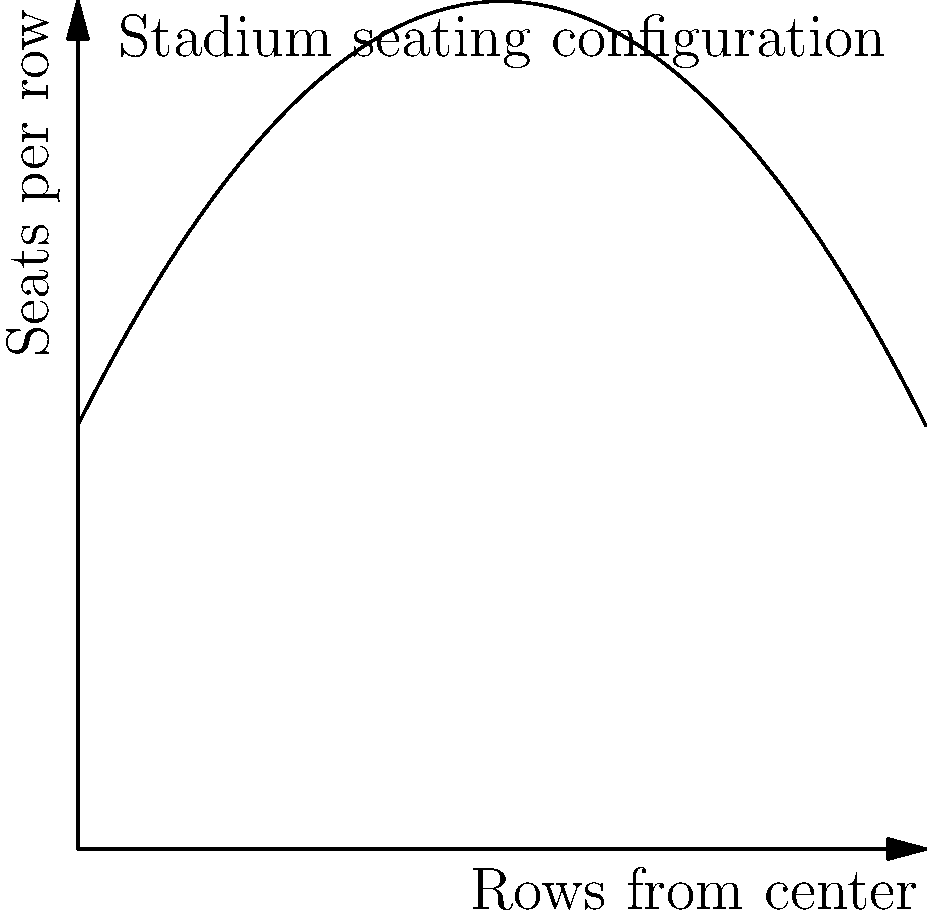The Red Star Belgrade stadium management is planning to optimize seating arrangements. The number of seats in each row can be modeled by the function $S(r) = -0.02r^2 + 2r + 50$, where $r$ is the number of rows from the center. If the stadium has 100 rows on each side of the center, what is the total seating capacity of the stadium? To find the total seating capacity, we need to:

1) Calculate the area under the curve $S(r) = -0.02r^2 + 2r + 50$ from $r=0$ to $r=100$.
2) Multiply this area by 2 to account for both sides of the stadium.

Step 1: Calculate the area under the curve
The area under a curve is given by the definite integral:

$$A = \int_0^{100} (-0.02r^2 + 2r + 50) dr$$

Step 2: Solve the integral
$$A = [-\frac{0.02r^3}{3} + r^2 + 50r]_0^{100}$$
$$A = [-\frac{0.02(100^3)}{3} + 100^2 + 50(100)] - [0]$$
$$A = [-6666.67 + 10000 + 5000] - 0$$
$$A = 8333.33$$

Step 3: Multiply by 2 for both sides of the stadium
Total capacity $= 2 \times 8333.33 = 16666.66$

Step 4: Round to the nearest whole number
Since we can't have fractional seats, we round down to 16,666.
Answer: 16,666 seats 